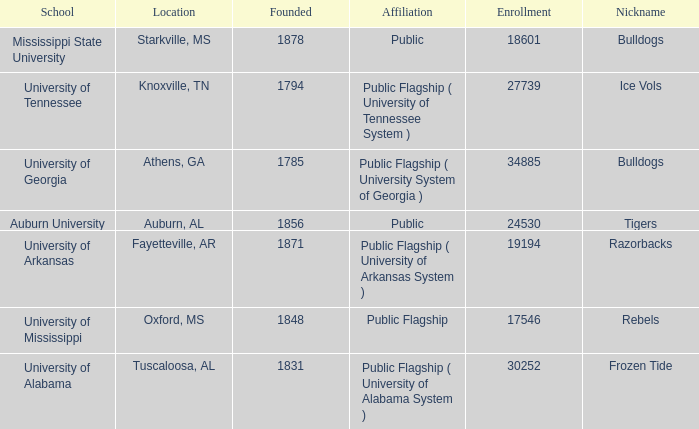What is the nickname of the University of Alabama? Frozen Tide. Could you parse the entire table? {'header': ['School', 'Location', 'Founded', 'Affiliation', 'Enrollment', 'Nickname'], 'rows': [['Mississippi State University', 'Starkville, MS', '1878', 'Public', '18601', 'Bulldogs'], ['University of Tennessee', 'Knoxville, TN', '1794', 'Public Flagship ( University of Tennessee System )', '27739', 'Ice Vols'], ['University of Georgia', 'Athens, GA', '1785', 'Public Flagship ( University System of Georgia )', '34885', 'Bulldogs'], ['Auburn University', 'Auburn, AL', '1856', 'Public', '24530', 'Tigers'], ['University of Arkansas', 'Fayetteville, AR', '1871', 'Public Flagship ( University of Arkansas System )', '19194', 'Razorbacks'], ['University of Mississippi', 'Oxford, MS', '1848', 'Public Flagship', '17546', 'Rebels'], ['University of Alabama', 'Tuscaloosa, AL', '1831', 'Public Flagship ( University of Alabama System )', '30252', 'Frozen Tide']]} 